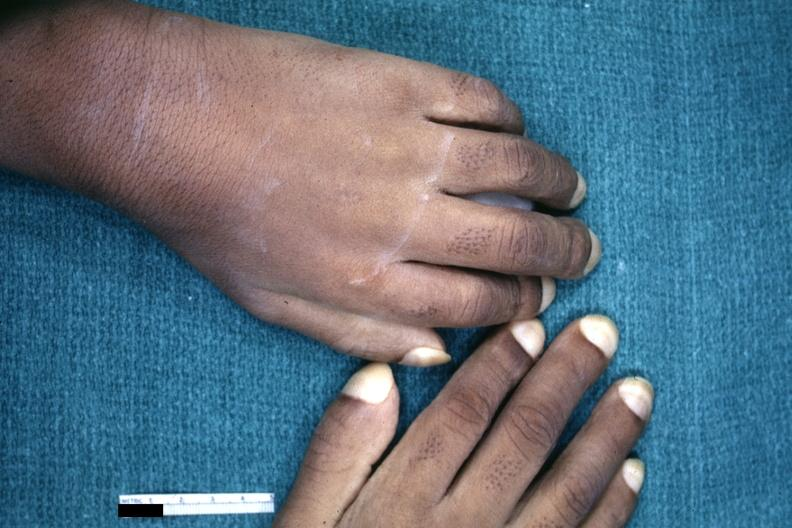does this image show childs hands with obvious clubbing?
Answer the question using a single word or phrase. Yes 